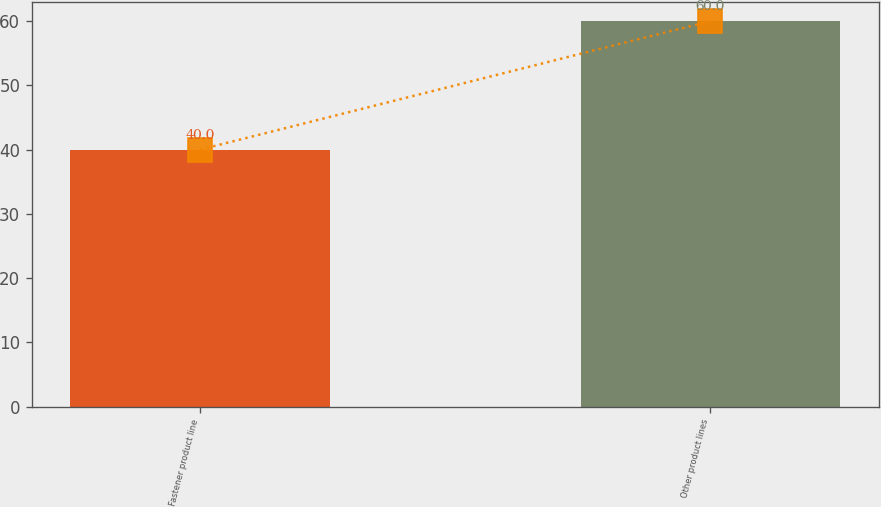<chart> <loc_0><loc_0><loc_500><loc_500><bar_chart><fcel>Fastener product line<fcel>Other product lines<nl><fcel>40<fcel>60<nl></chart> 